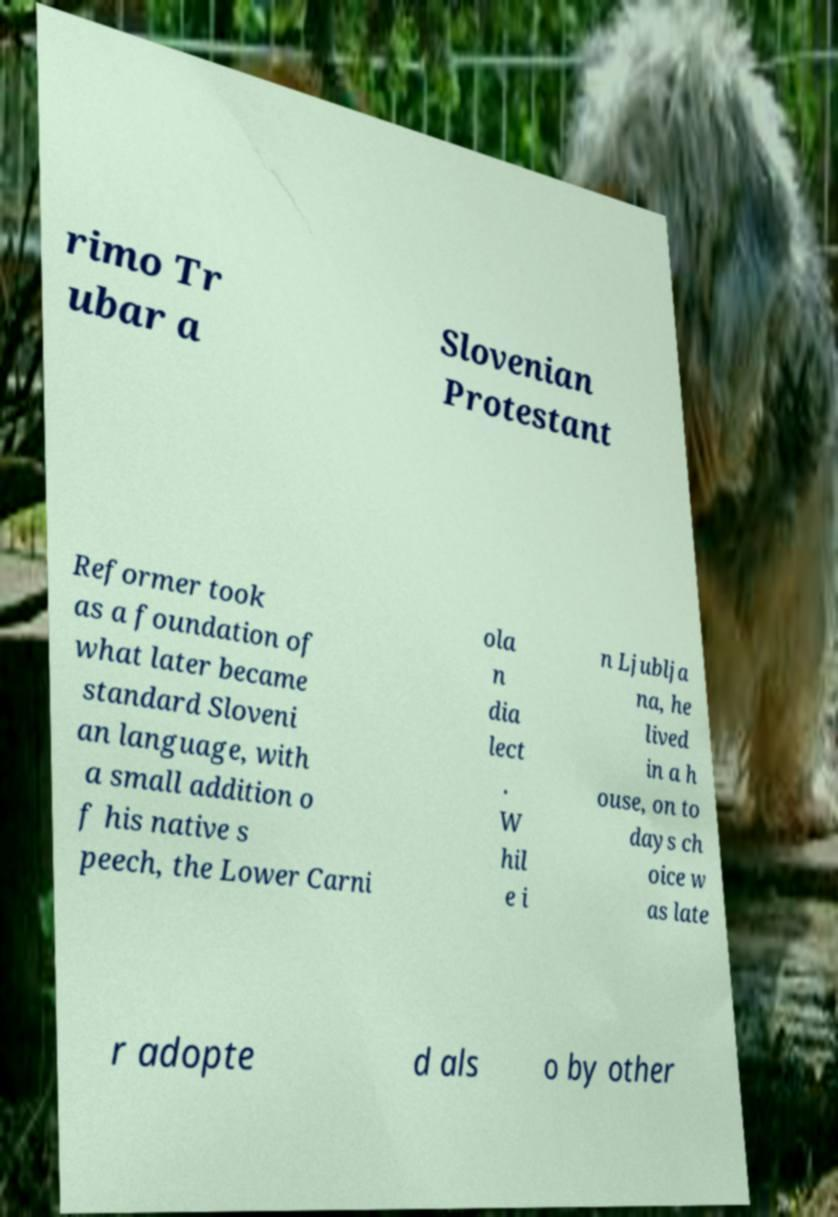Could you assist in decoding the text presented in this image and type it out clearly? rimo Tr ubar a Slovenian Protestant Reformer took as a foundation of what later became standard Sloveni an language, with a small addition o f his native s peech, the Lower Carni ola n dia lect . W hil e i n Ljublja na, he lived in a h ouse, on to days ch oice w as late r adopte d als o by other 